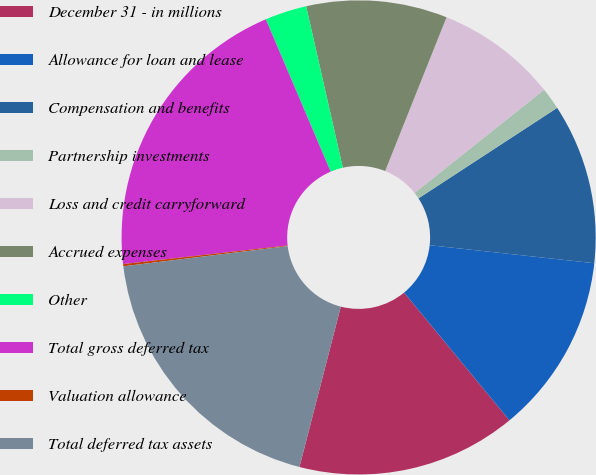Convert chart to OTSL. <chart><loc_0><loc_0><loc_500><loc_500><pie_chart><fcel>December 31 - in millions<fcel>Allowance for loan and lease<fcel>Compensation and benefits<fcel>Partnership investments<fcel>Loss and credit carryforward<fcel>Accrued expenses<fcel>Other<fcel>Total gross deferred tax<fcel>Valuation allowance<fcel>Total deferred tax assets<nl><fcel>14.99%<fcel>12.29%<fcel>10.94%<fcel>1.5%<fcel>8.25%<fcel>9.6%<fcel>2.85%<fcel>20.39%<fcel>0.15%<fcel>19.04%<nl></chart> 